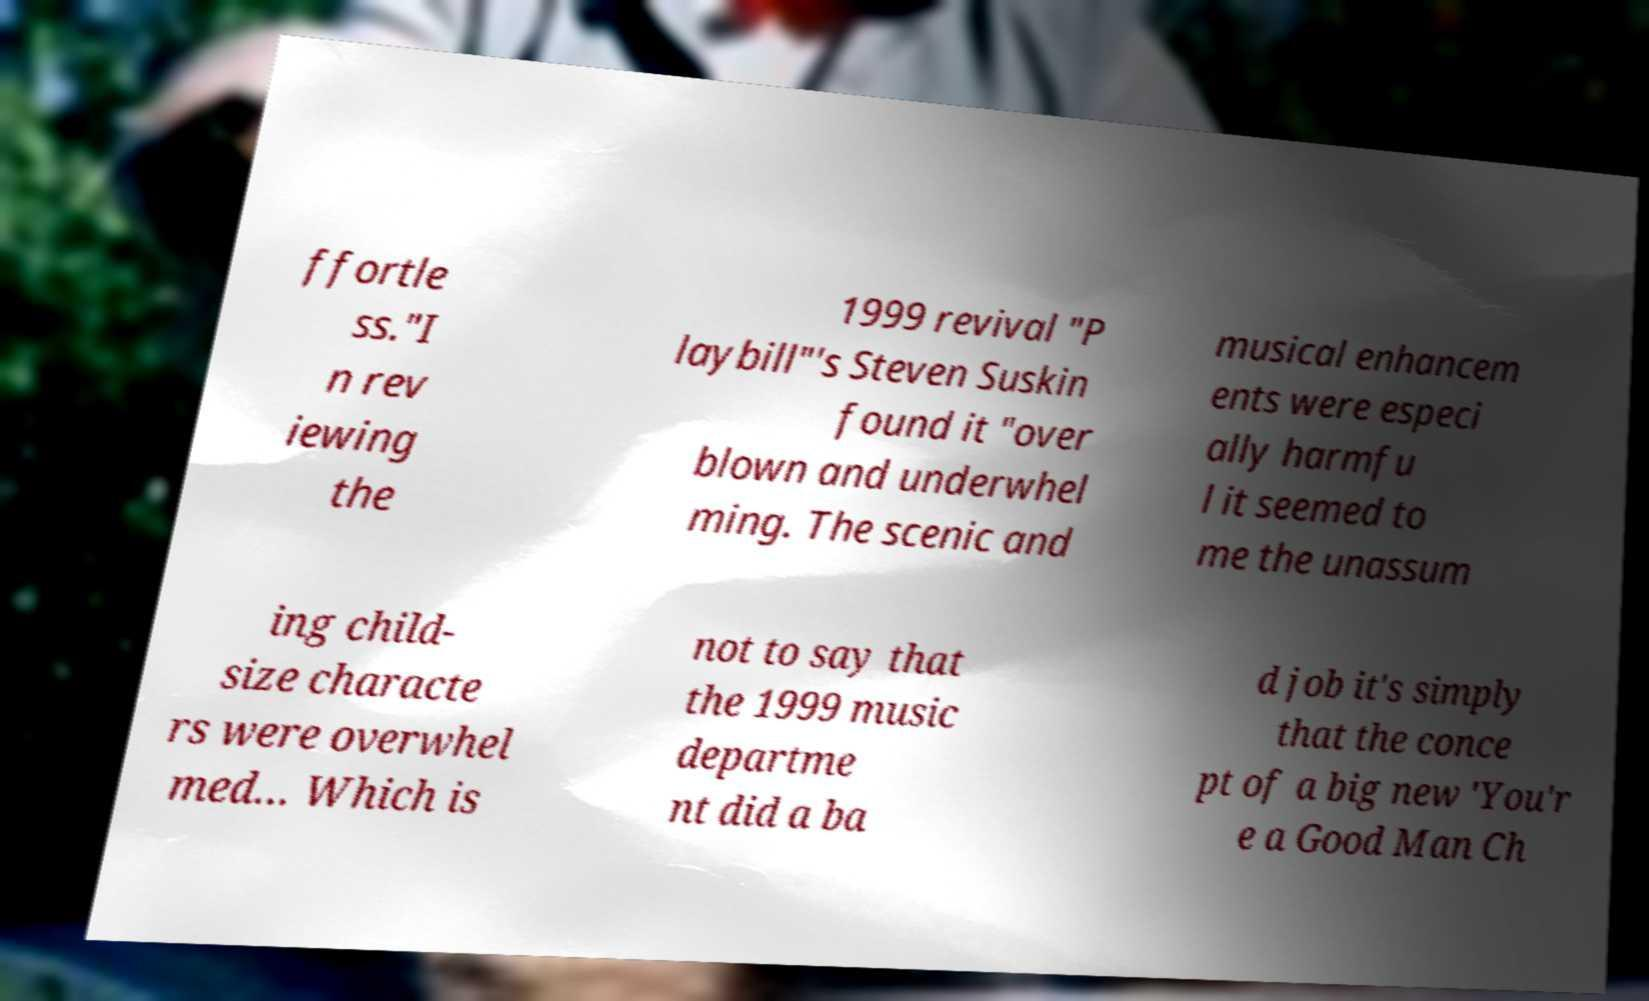There's text embedded in this image that I need extracted. Can you transcribe it verbatim? ffortle ss."I n rev iewing the 1999 revival "P laybill"'s Steven Suskin found it "over blown and underwhel ming. The scenic and musical enhancem ents were especi ally harmfu l it seemed to me the unassum ing child- size characte rs were overwhel med… Which is not to say that the 1999 music departme nt did a ba d job it's simply that the conce pt of a big new 'You'r e a Good Man Ch 